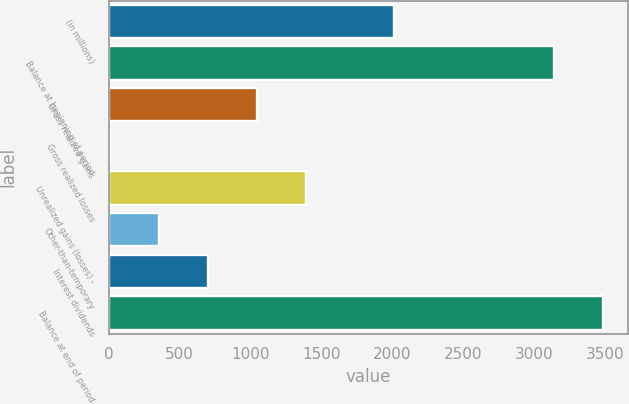Convert chart. <chart><loc_0><loc_0><loc_500><loc_500><bar_chart><fcel>(in millions)<fcel>Balance at beginning of period<fcel>Gross realized gains<fcel>Gross realized losses<fcel>Unrealized gains (losses) -<fcel>Other-than-temporary<fcel>Interest dividends<fcel>Balance at end of period<nl><fcel>2010<fcel>3140<fcel>1046.8<fcel>4<fcel>1394.4<fcel>351.6<fcel>699.2<fcel>3487.6<nl></chart> 